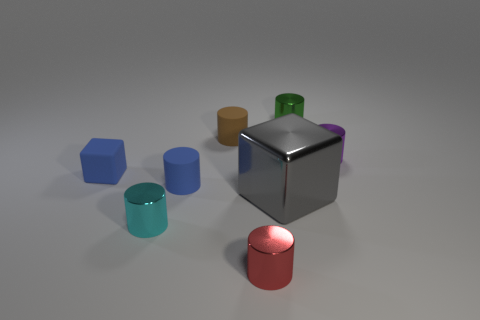Are there any other things that have the same size as the gray metallic thing?
Your answer should be compact. No. Is there a red metal object that has the same size as the gray metallic thing?
Your response must be concise. No. What number of things are tiny metallic cylinders that are to the left of the green shiny cylinder or small shiny cylinders right of the cyan metal object?
Give a very brief answer. 4. What is the shape of the red object that is the same size as the purple metallic object?
Ensure brevity in your answer.  Cylinder. Are there any cyan things that have the same shape as the small purple metallic thing?
Offer a very short reply. Yes. Are there fewer small yellow metal cylinders than brown rubber cylinders?
Your answer should be very brief. Yes. There is a shiny thing that is behind the purple cylinder; does it have the same size as the blue thing that is to the left of the tiny cyan cylinder?
Keep it short and to the point. Yes. How many objects are either big gray cubes or small purple things?
Make the answer very short. 2. What size is the block on the right side of the red cylinder?
Give a very brief answer. Large. There is a matte object behind the cube behind the gray cube; how many shiny things are in front of it?
Ensure brevity in your answer.  4. 